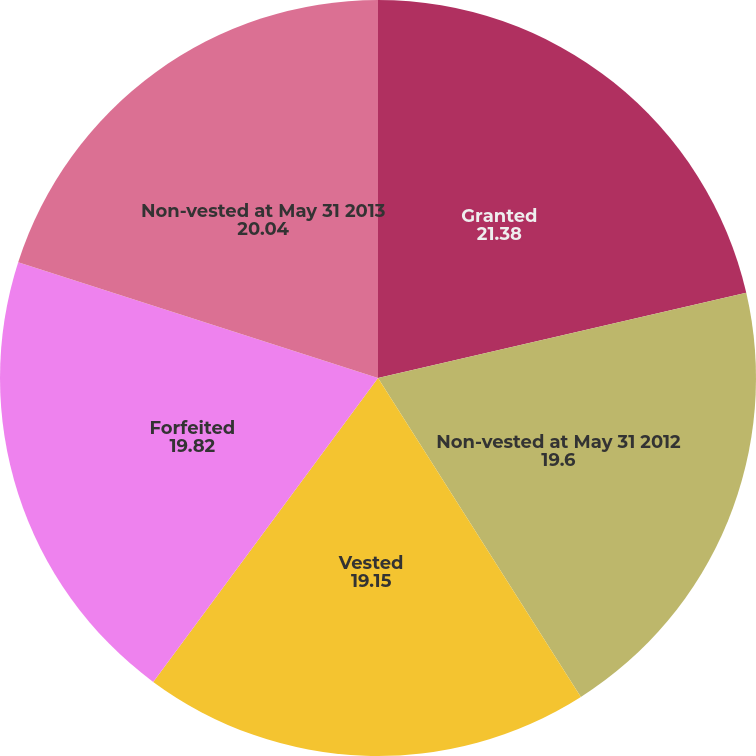Convert chart. <chart><loc_0><loc_0><loc_500><loc_500><pie_chart><fcel>Granted<fcel>Non-vested at May 31 2012<fcel>Vested<fcel>Forfeited<fcel>Non-vested at May 31 2013<nl><fcel>21.38%<fcel>19.6%<fcel>19.15%<fcel>19.82%<fcel>20.04%<nl></chart> 